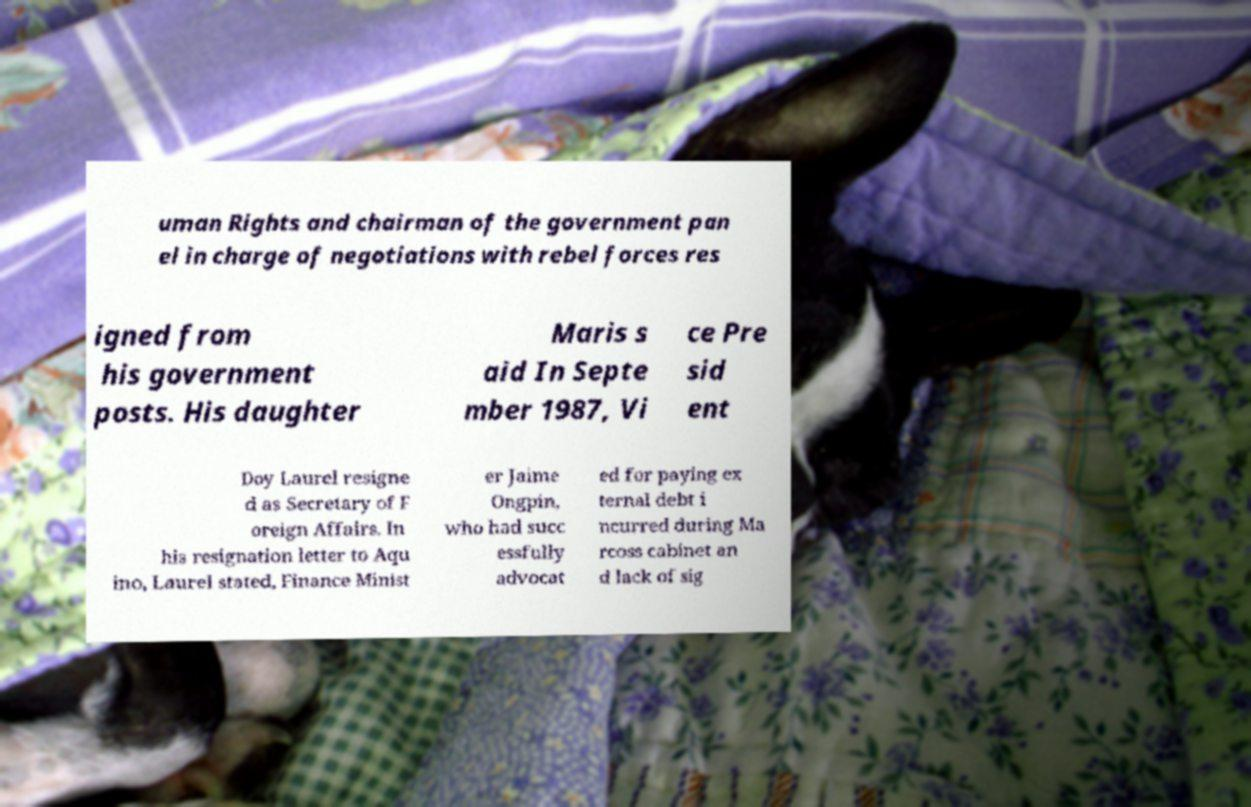What messages or text are displayed in this image? I need them in a readable, typed format. uman Rights and chairman of the government pan el in charge of negotiations with rebel forces res igned from his government posts. His daughter Maris s aid In Septe mber 1987, Vi ce Pre sid ent Doy Laurel resigne d as Secretary of F oreign Affairs. In his resignation letter to Aqu ino, Laurel stated, Finance Minist er Jaime Ongpin, who had succ essfully advocat ed for paying ex ternal debt i ncurred during Ma rcoss cabinet an d lack of sig 